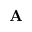Convert formula to latex. <formula><loc_0><loc_0><loc_500><loc_500>A</formula> 